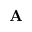Convert formula to latex. <formula><loc_0><loc_0><loc_500><loc_500>A</formula> 